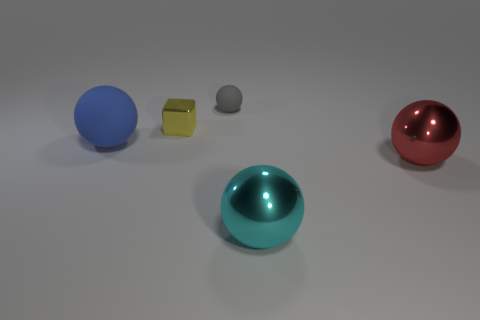Is the big cyan ball made of the same material as the small block?
Give a very brief answer. Yes. There is a matte thing that is behind the matte object that is in front of the tiny matte thing; what number of large spheres are to the right of it?
Give a very brief answer. 2. What is the shape of the big thing in front of the red ball?
Offer a terse response. Sphere. What number of other things are there of the same material as the tiny gray object
Provide a short and direct response. 1. Is the number of blue rubber balls in front of the large blue ball less than the number of things left of the gray rubber ball?
Give a very brief answer. Yes. What color is the other large metallic object that is the same shape as the red metal thing?
Ensure brevity in your answer.  Cyan. There is a matte object behind the blue thing; does it have the same size as the yellow block?
Provide a short and direct response. Yes. Is the number of big blue balls in front of the yellow thing less than the number of balls?
Keep it short and to the point. Yes. There is a matte object that is left of the matte object to the right of the tiny yellow metal cube; what is its size?
Provide a short and direct response. Large. Are there any other things that are the same shape as the yellow object?
Ensure brevity in your answer.  No. 